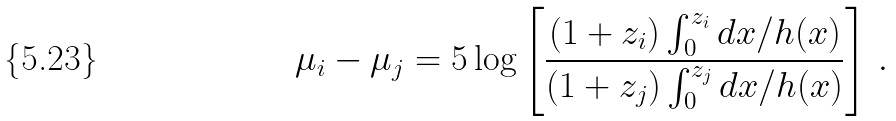Convert formula to latex. <formula><loc_0><loc_0><loc_500><loc_500>\mu _ { i } - \mu _ { j } = 5 \log \left [ \frac { ( 1 + z _ { i } ) \int _ { 0 } ^ { z _ { i } } d x / h ( x ) } { ( 1 + z _ { j } ) \int _ { 0 } ^ { z _ { j } } d x / h ( x ) } \right ] \, .</formula> 